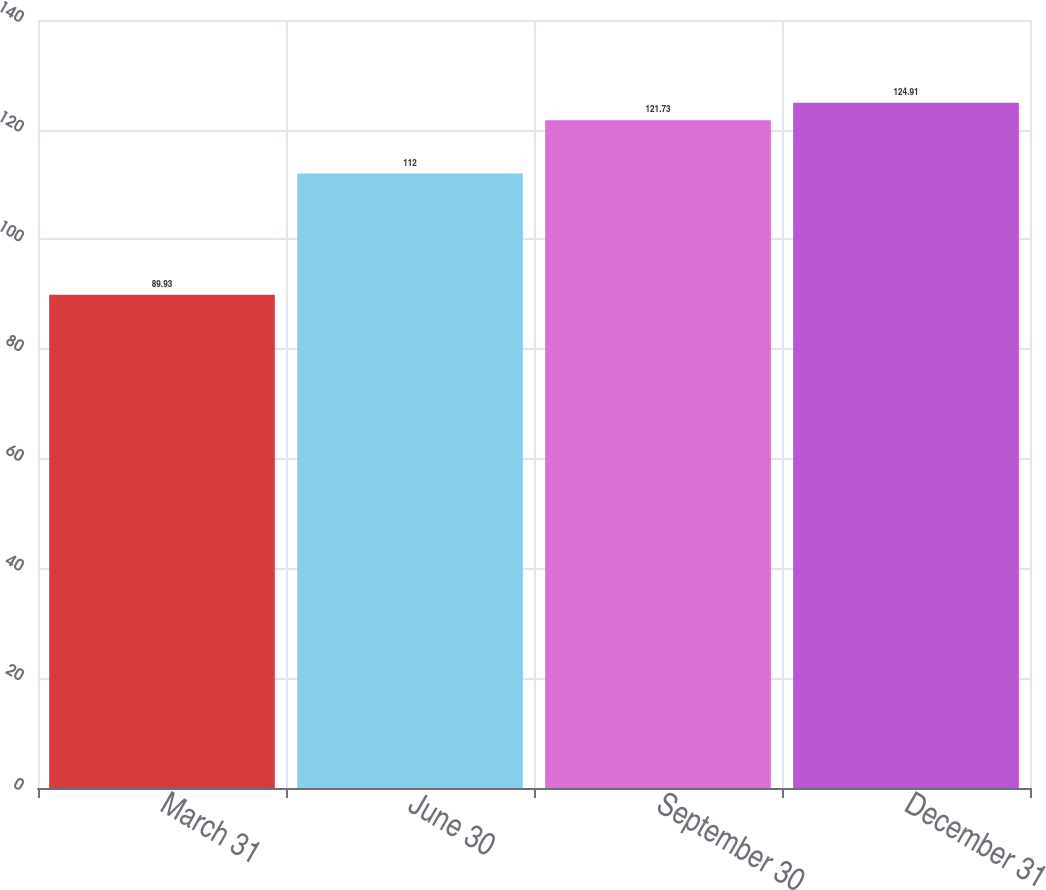Convert chart to OTSL. <chart><loc_0><loc_0><loc_500><loc_500><bar_chart><fcel>March 31<fcel>June 30<fcel>September 30<fcel>December 31<nl><fcel>89.93<fcel>112<fcel>121.73<fcel>124.91<nl></chart> 